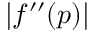<formula> <loc_0><loc_0><loc_500><loc_500>\left | f ^ { \prime \prime } ( p ) \right |</formula> 